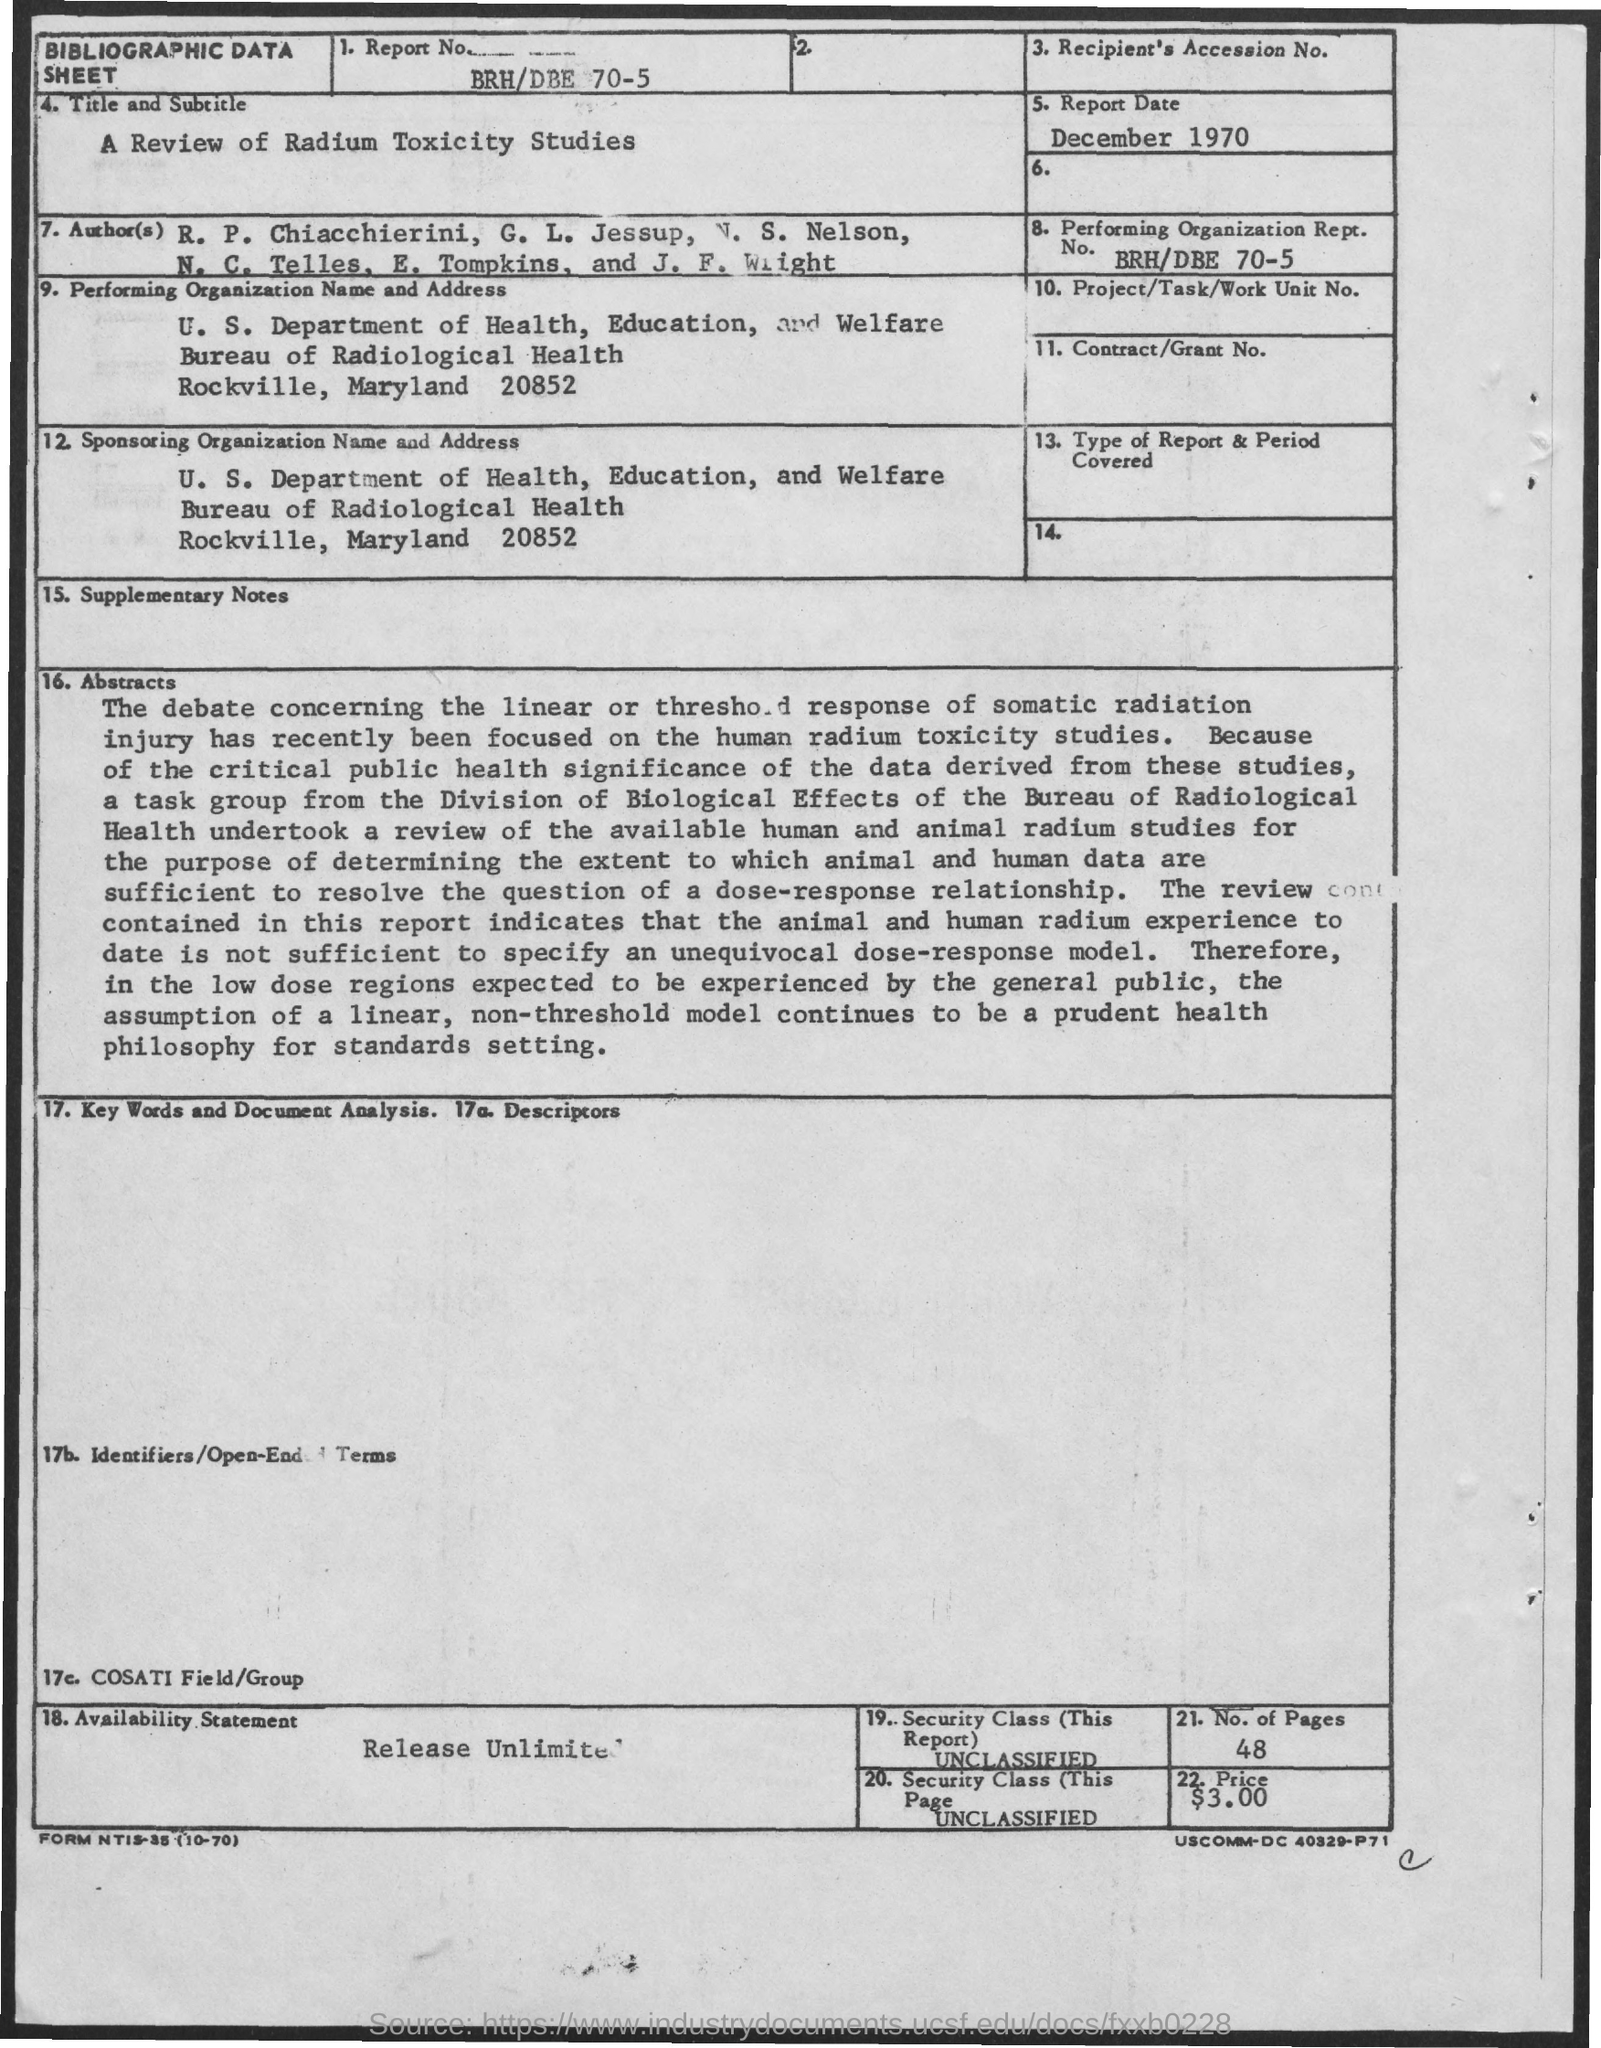When is the Report Date ?
Offer a terse response. December 1970. What is the Report Number ?
Ensure brevity in your answer.  BRH/DBE 70-5. 